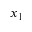Convert formula to latex. <formula><loc_0><loc_0><loc_500><loc_500>x _ { 1 }</formula> 